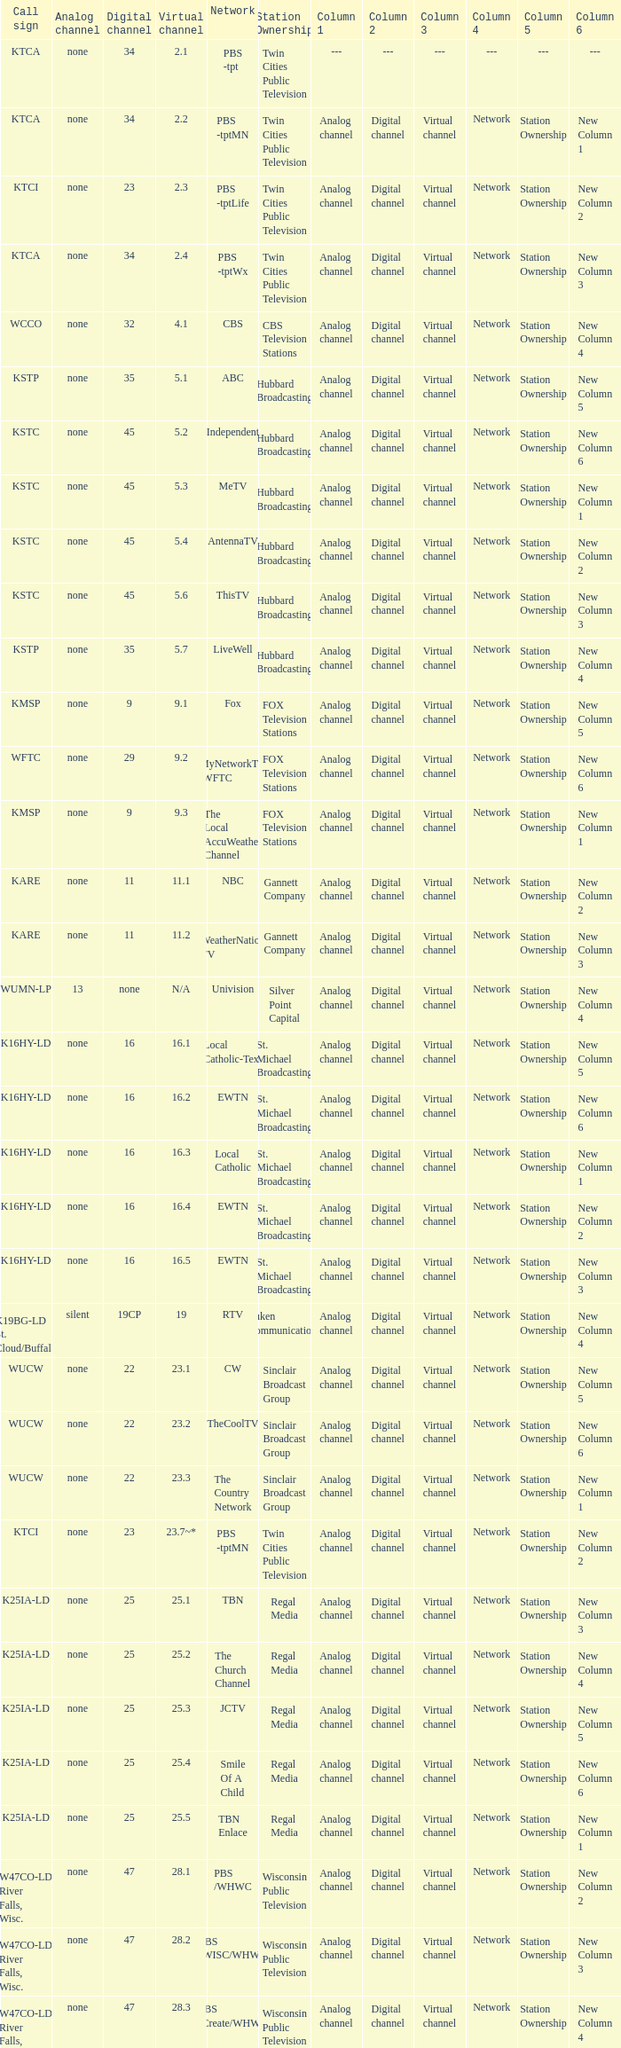Station Ownership of eicb tv, and a Call sign of ktcj-ld is what virtual network? 50.1. 